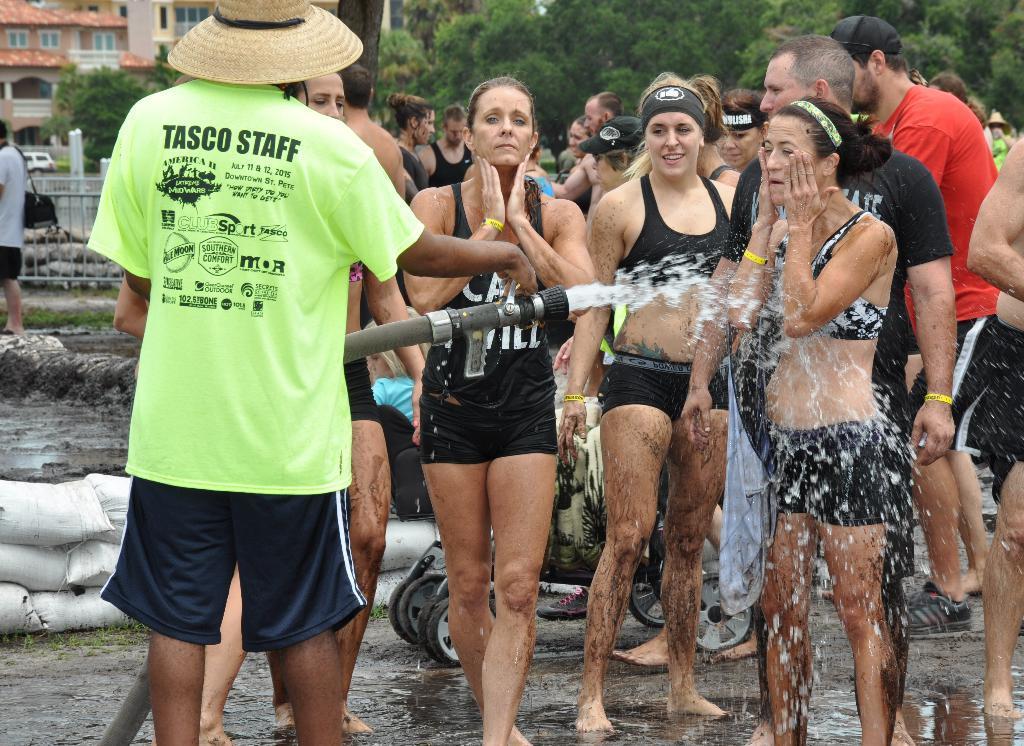How would you summarize this image in a sentence or two? In this image I can see number of people are standing. I can see most of them are wearing black dress and few of them are wearing caps. Here I can see one of them is holding a pipe. In the background I can see few white colour bags, number of trees, few buildings and a vehicle over there. 